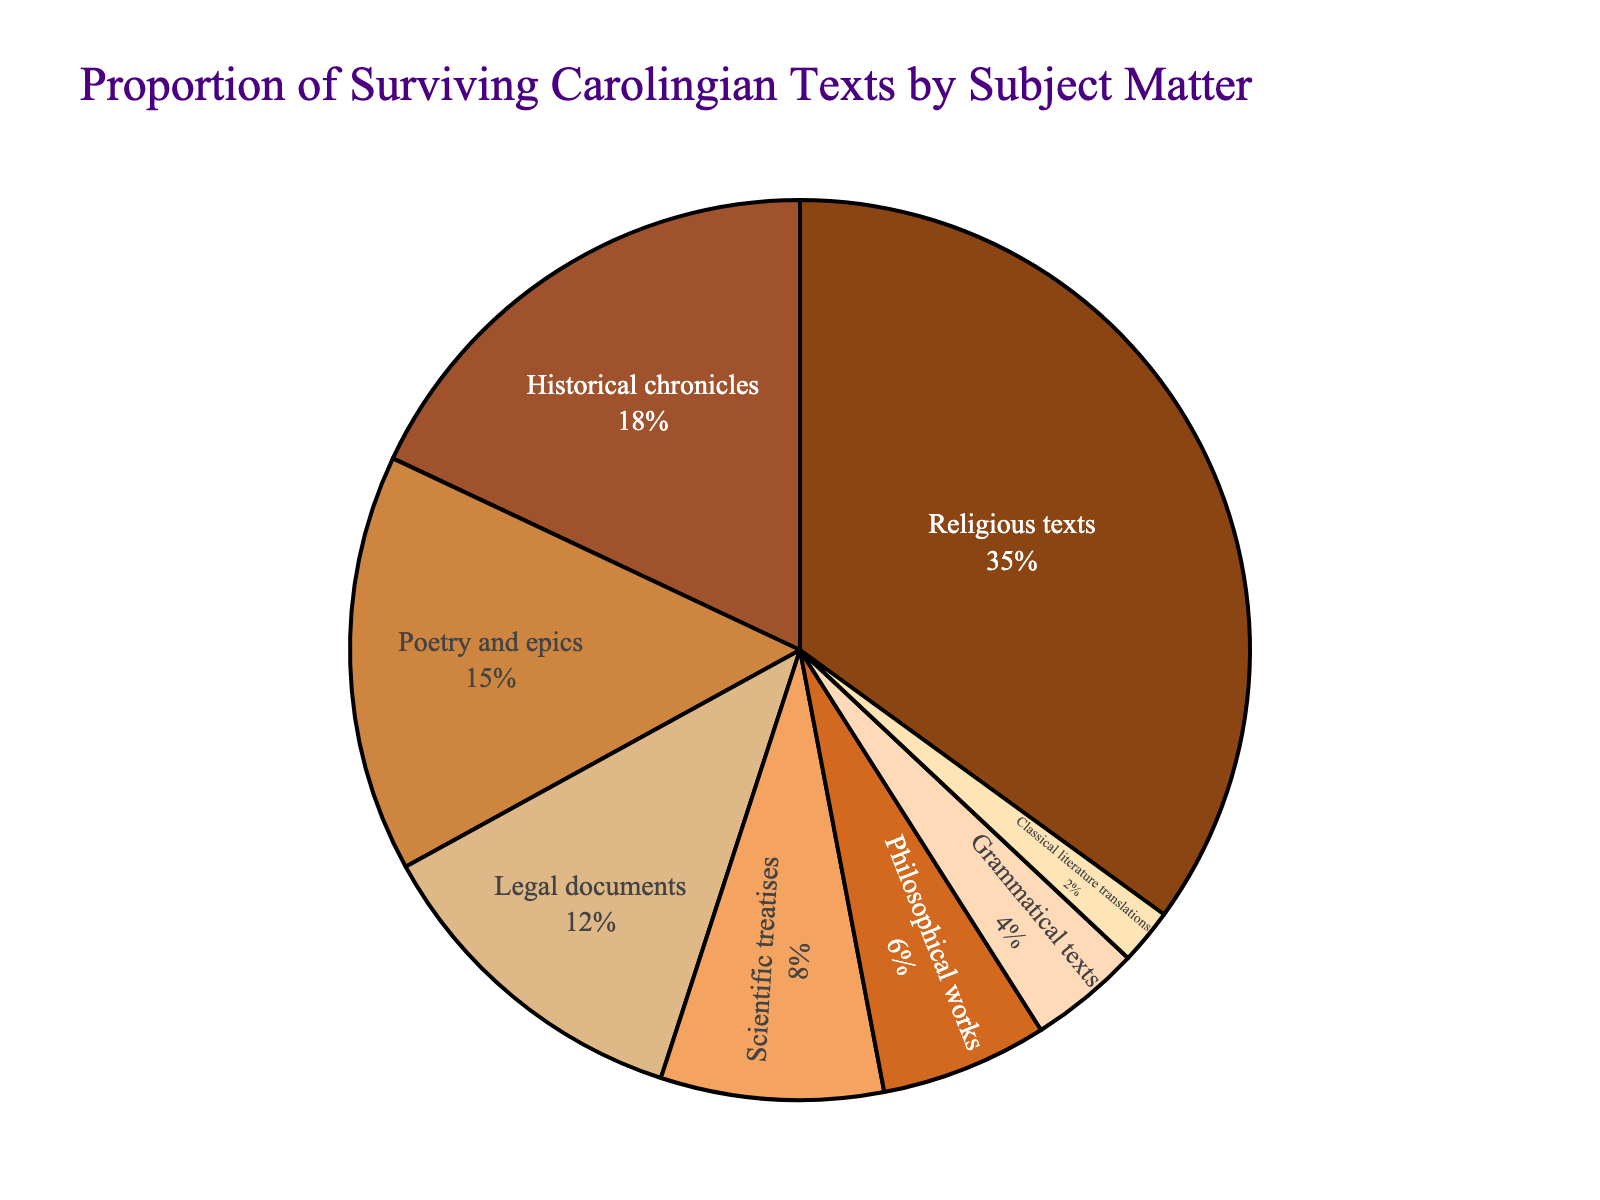What percentage of the texts are historical chronicles? Look at the pie chart and find the segment labeled 'Historical chronicles'. The associated percentage is clearly indicated.
Answer: 18% What is the combined percentage of legal documents and philosophical works? Identify the percentages for 'Legal documents' and 'Philosophical works' from the chart. Add 12% and 6% to find the combined percentage.
Answer: 18% Which subject matter has the smallest proportion of surviving texts? Observe the chart and determine which segment has the smallest percentage. The segment 'Classical literature translations' has the smallest proportion.
Answer: Classical literature translations Are there more scientific treatises or historical chronicles? Compare the percentages for 'Scientific treatises' (8%) and 'Historical chronicles' (18%). Historical chronicles have a larger percentage.
Answer: Historical chronicles If you exclude religious texts, what percentage do the remaining subjects account for together? First, subtract the percentage of 'Religious texts' (35%) from the total (100%). The remaining percentage is 100% - 35% = 65%.
Answer: 65% Which subjects have a lower proportion of texts than philosophical works? Identify the percentage for 'Philosophical works' (6%), then find any subjects with a lower percentage: 'Grammatical texts' (4%) and 'Classical literature translations' (2%).
Answer: Grammatical texts, Classical literature translations How does the proportion of poetry and epics compare to scientific treatises? Locate the percentages for 'Poetry and epics' (15%) and 'Scientific treatises' (8%). Poetry and epics have a higher percentage.
Answer: Poetry and epics have a higher proportion What are the colors associated with religious texts and historical chronicles? Examine the segments labeled 'Religious texts' and 'Historical chronicles'. Identify their colors. 'Religious texts' is brown and 'Historical chronicles' is a darker brown.
Answer: Brown for Religious texts, Darker brown for Historical chronicles What is the difference in percentage between grammatical texts and legal documents? Compare the percentages for 'Grammatical texts' (4%) and 'Legal documents' (12%). Subtract 4% from 12% to find the difference.
Answer: 8% 